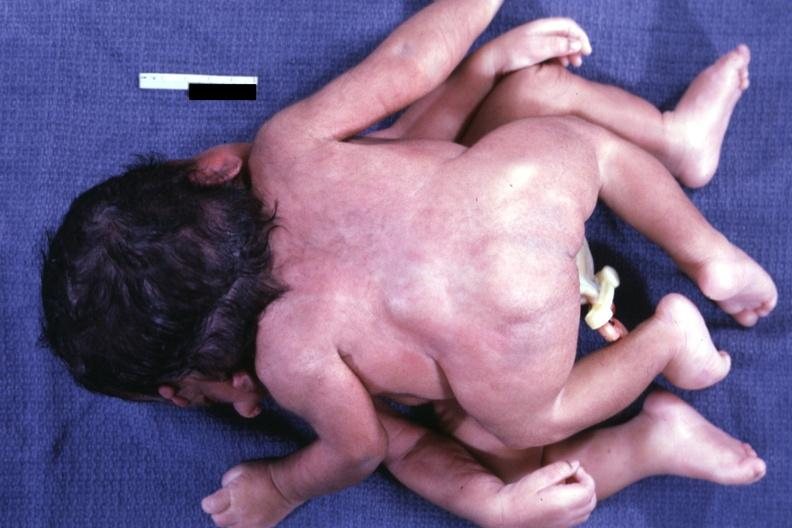what is present?
Answer the question using a single word or phrase. Conjoined twins cephalothoracopagus janiceps 